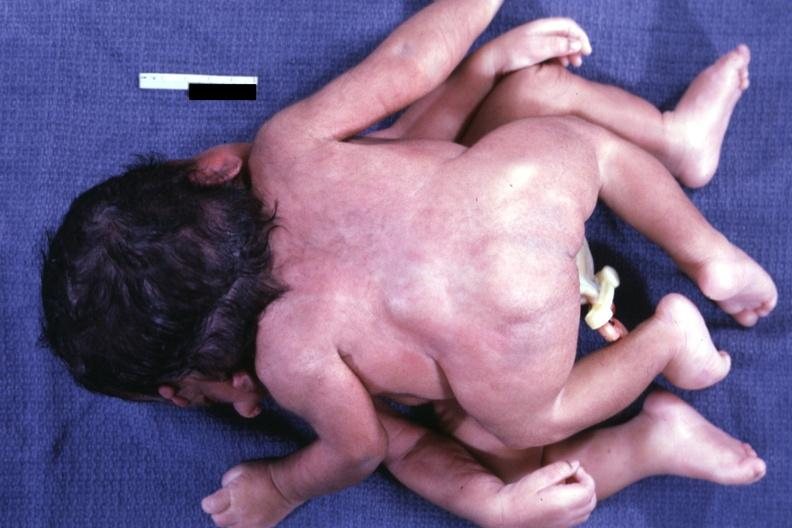what is present?
Answer the question using a single word or phrase. Conjoined twins cephalothoracopagus janiceps 